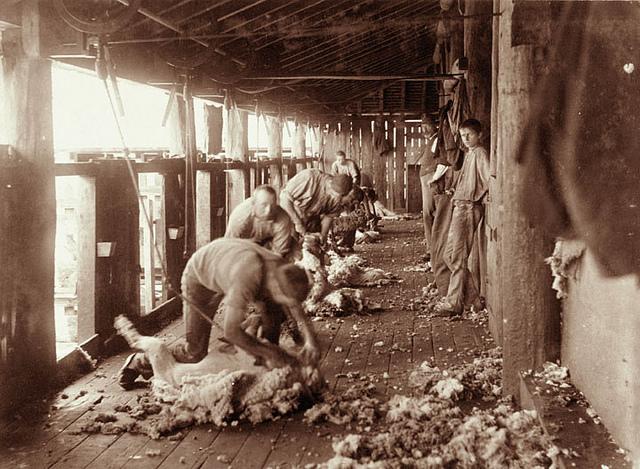What are the men in this picture doing?
Answer briefly. Shearing sheep. Is this photo in color?
Be succinct. No. What do you think the boy is thinking?
Keep it brief. He is tired. 